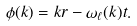<formula> <loc_0><loc_0><loc_500><loc_500>\phi ( k ) = k r - \omega _ { \ell } ( k ) t .</formula> 